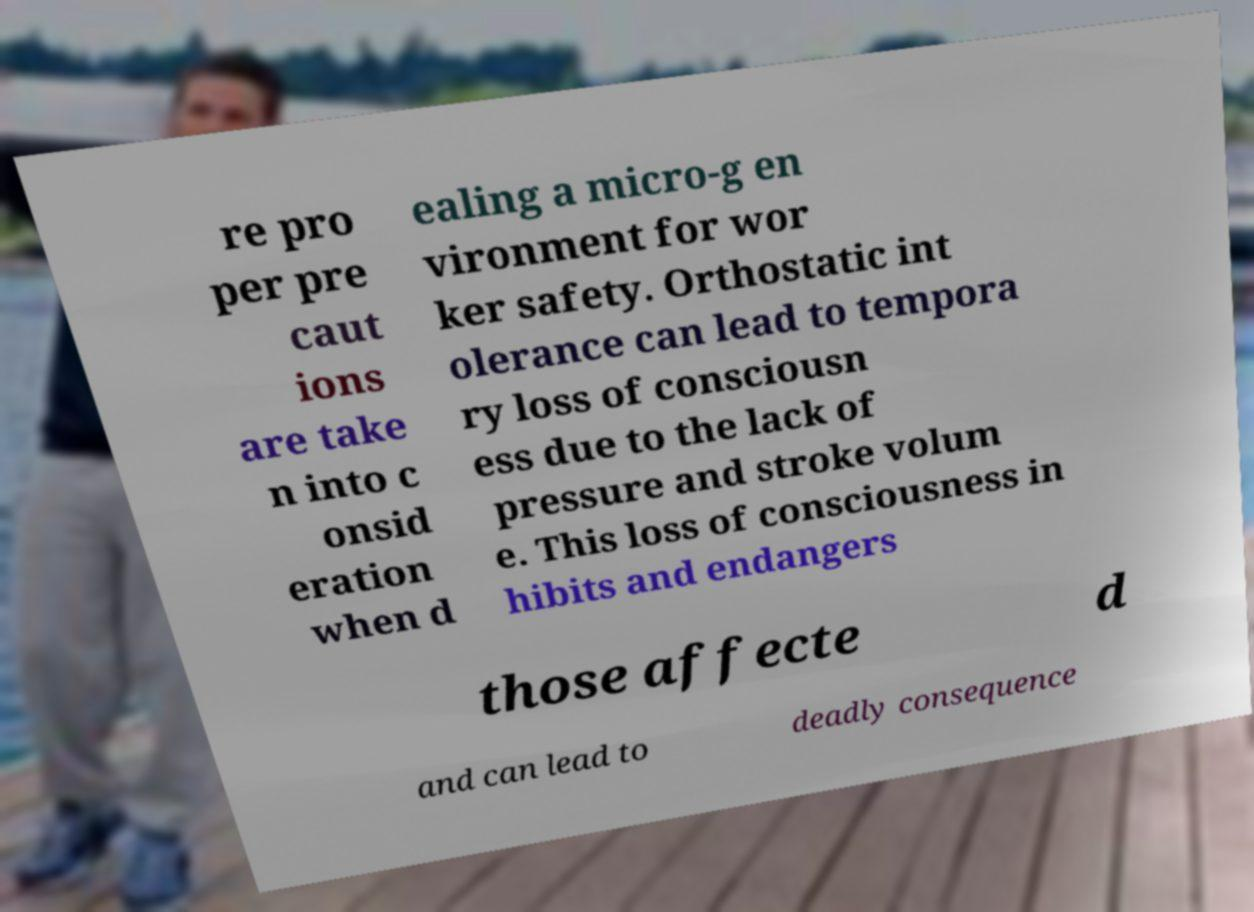For documentation purposes, I need the text within this image transcribed. Could you provide that? re pro per pre caut ions are take n into c onsid eration when d ealing a micro-g en vironment for wor ker safety. Orthostatic int olerance can lead to tempora ry loss of consciousn ess due to the lack of pressure and stroke volum e. This loss of consciousness in hibits and endangers those affecte d and can lead to deadly consequence 